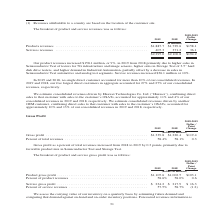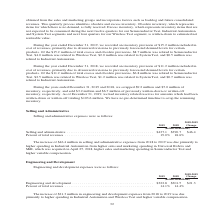According to Teradyne's financial document, How is the carrying value of inventory assessed? on a quarterly basis by estimating future demand and comparing that demand against on-hand and on-order inventory positions.. The document states: "We assess the carrying value of our inventory on a quarterly basis by estimating future demand and comparing that demand against on-hand and on-order ..." Also, What are the types of gross profit in the table? The document shows two values: Product gross profit and Service gross profit. From the document: "(dollars in millions) Product gross profit . $1,105.6 $1,002.5 $103.1 Percent of product revenues . 58.6% 58.0% 0.6 The breakout of product and servic..." Also, In which years was the  breakout of product and service gross profit provided? The document shows two values: 2019 and 2018. From the document: "2019 2018 2019 2018..." Additionally, In which year was service gross profit larger? According to the financial document, 2019. The relevant text states: "2019 2018..." Also, can you calculate: What was the percentage change in service gross profit from 2018 to 2019? To answer this question, I need to perform calculations using the financial data. The calculation is: (234.2-217.9)/217.9, which equals 7.48 (percentage). This is based on the information: "Service gross profit . $ 234.2 $ 217.9 $ 16.3 Percent of service revenues . 57.5% 58.7% (1.2) Service gross profit . $ 234.2 $ 217.9 $ 16.3 Percent of service revenues . 57.5% 58.7% (1.2)..." The key data points involved are: 217.9, 234.2. Also, can you calculate: What was the percentage change in product gross profit from 2018 to 2019? To answer this question, I need to perform calculations using the financial data. The calculation is: (1,105.6-1,002.5)/1,002.5, which equals 10.28 (percentage). This is based on the information: "ars in millions) Product gross profit . $1,105.6 $1,002.5 $103.1 Percent of product revenues . 58.6% 58.0% 0.6 (dollars in millions) Product gross profit . $1,105.6 $1,002.5 $103.1 Percent of product ..." The key data points involved are: 1,002.5, 1,105.6. 